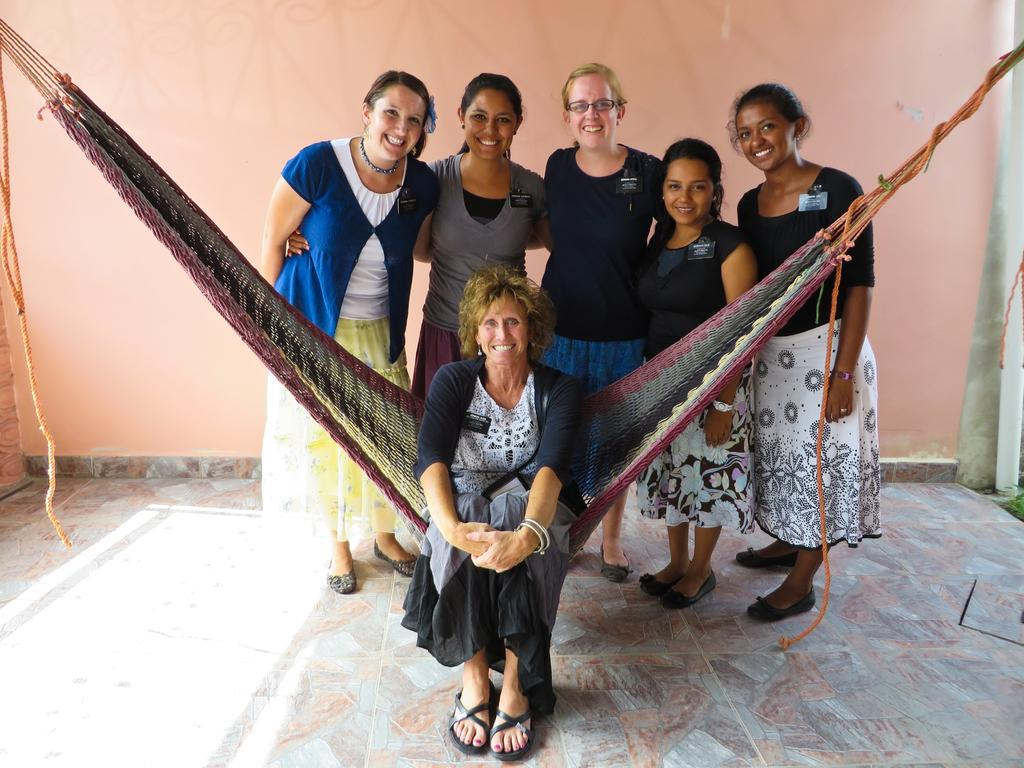What are the people in the image doing? The people in the image are standing. What is the woman in the image doing? The woman in the image is sitting. What can be seen in the background of the image? There is a wall in the background of the image. What type of rice is being served at the birthday party in the image? There is no mention of rice or a birthday party in the image, so it cannot be determined from the image. 